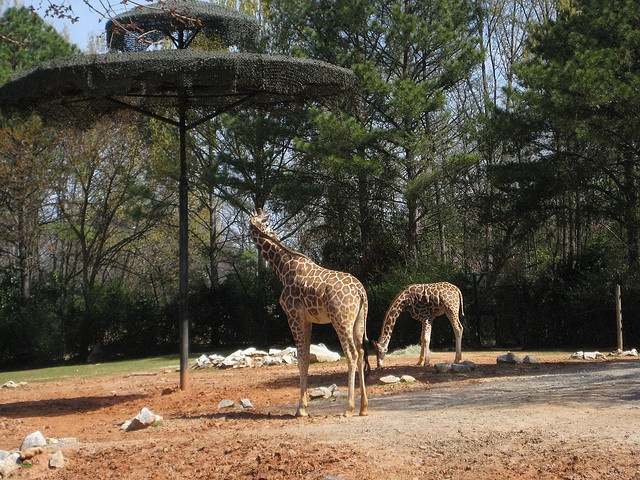Describe the objects in this image and their specific colors. I can see umbrella in darkgray, black, gray, and darkgreen tones, giraffe in darkgray, gray, black, and maroon tones, and giraffe in darkgray, black, maroon, and gray tones in this image. 